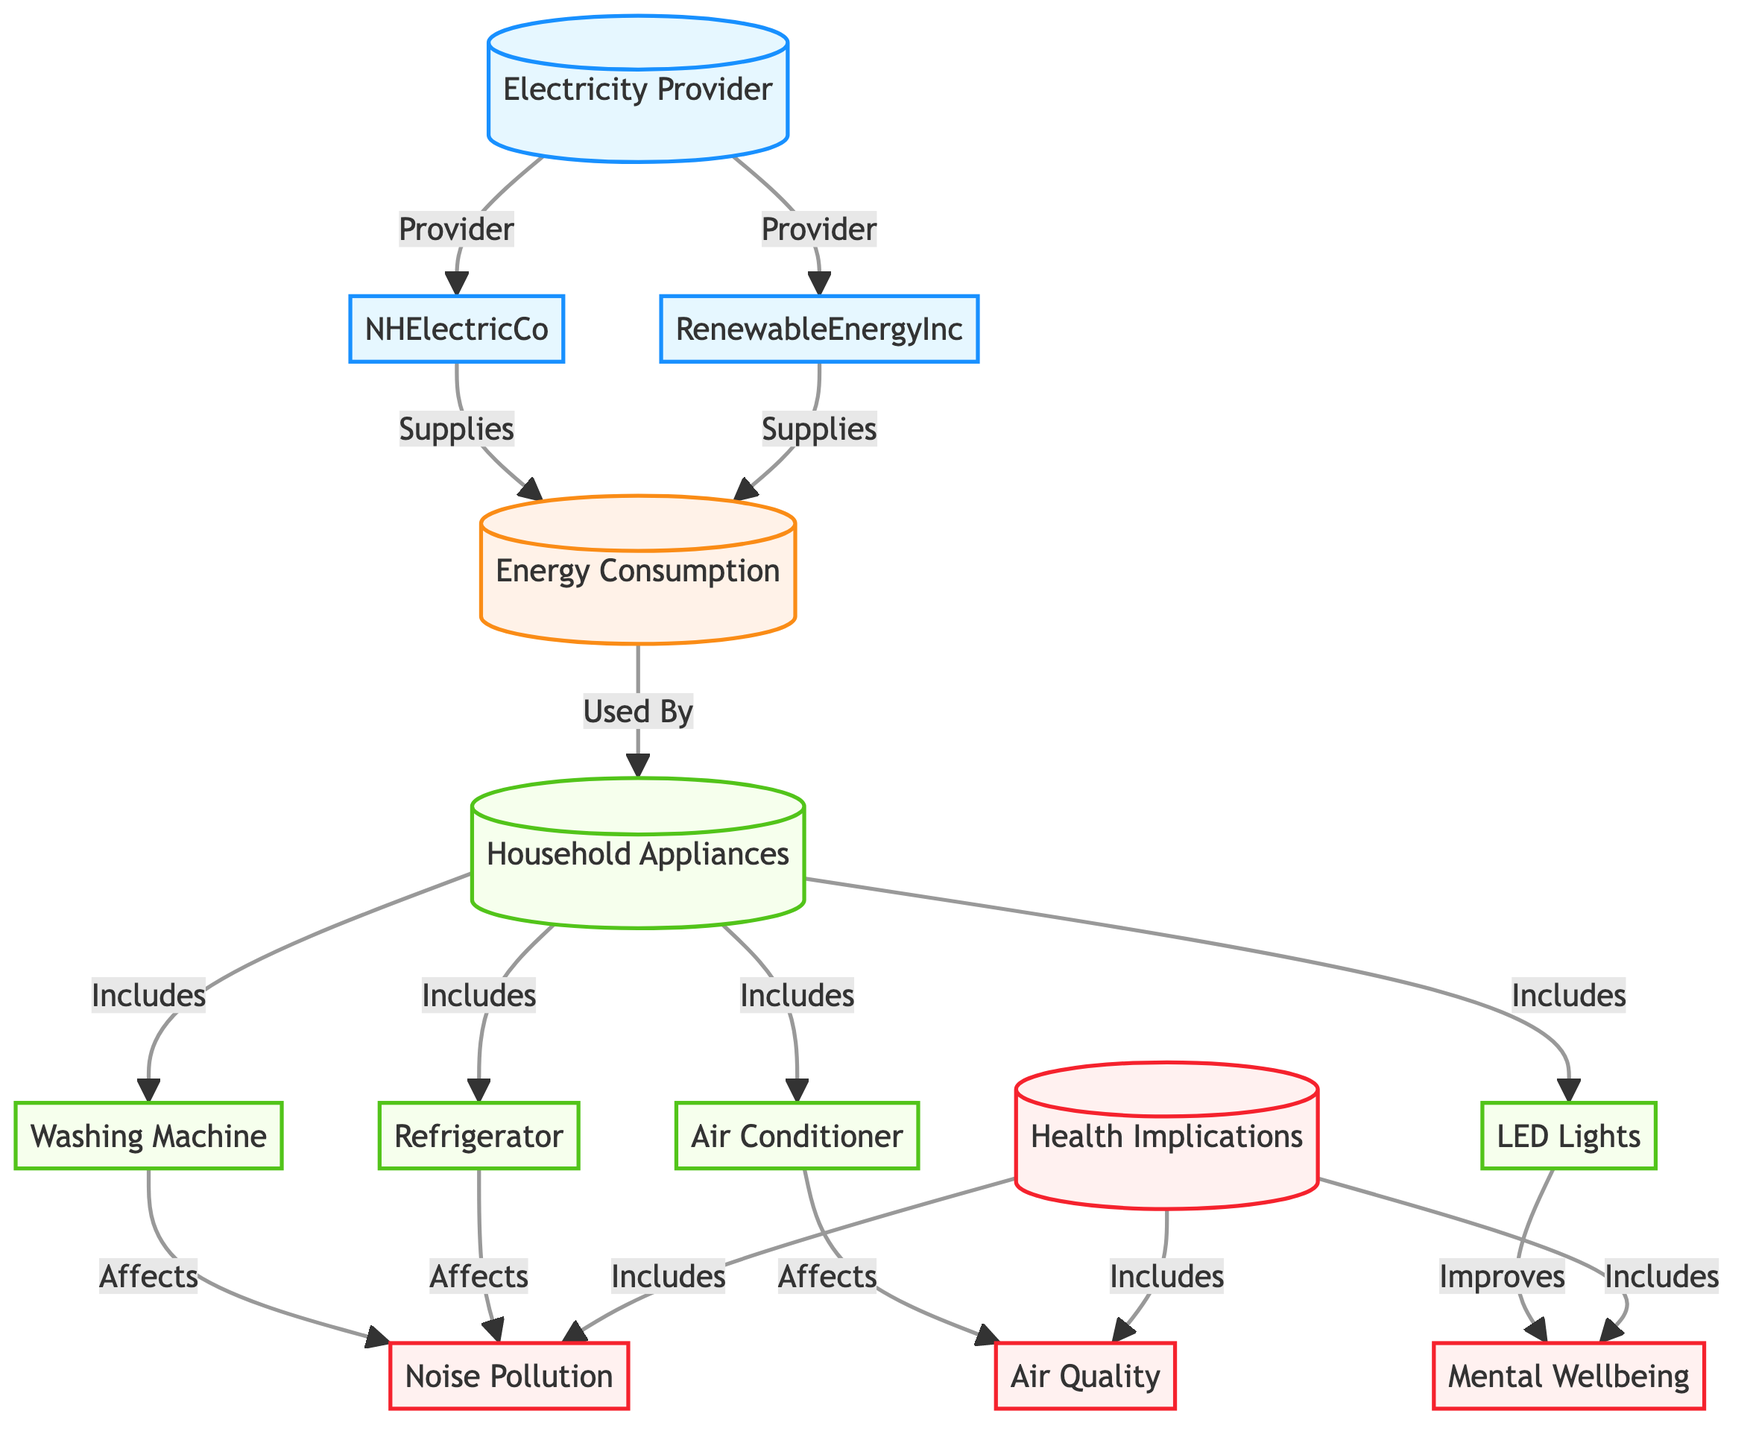What are the two electricity providers represented in the diagram? The diagram shows two nodes under the "Electricity Provider" category: "NHElectricCo" and "RenewableEnergyInc." These nodes represent the different providers supplying electricity.
Answer: NHElectricCo, RenewableEnergyInc How many household appliances are listed in the diagram? The diagram specifies four household appliances: "Washing Machine," "Refrigerator," "Air Conditioner," and "LED Lights." By counting these nodes, we find there are four.
Answer: 4 Which appliance affects noise pollution? The "Washing Machine" and "Refrigerator" nodes in the diagram both have an outgoing relationship labeled "Affects" directed towards "Noise Pollution," indicating they influence this health implication.
Answer: Washing Machine, Refrigerator What are the health implications included in the diagram? The diagram illustrates three health implications: "Air Quality," "Noise Pollution," and "Mental Wellbeing." These nodes are tied to the health implications category, summarizing the effects of household appliances on health.
Answer: Air Quality, Noise Pollution, Mental Wellbeing Which appliance improves mental wellbeing? The "LED Lights" node is connected with an "Improves" relationship directed towards "Mental Wellbeing," indicating its positive effect on this health aspect.
Answer: LED Lights How does renewable energy influence energy consumption? The connection between "RenewableEnergyInc" and "Energy Consumption" shows that it supplies energy, indicating that using this provider allows households to consume energy generated from renewable sources, possibly having a lower environmental impact.
Answer: Supplies energy What implications do air conditioners have on household health? The "Air Conditioner" node has a relationship labeled "Affects" which points to "Air Quality," indicating that this appliance impacts the quality of air in the household, a significant factor for health.
Answer: Air Quality Which electricity provider has a direct connection to energy consumption? Both "NHElectricCo" and "RenewableEnergyInc" have direct connections to "Energy Consumption," showing that they supply electricity, but the question specifically asks for one provider. Any one of these is an acceptable answer.
Answer: NHElectricCo or RenewableEnergyInc 